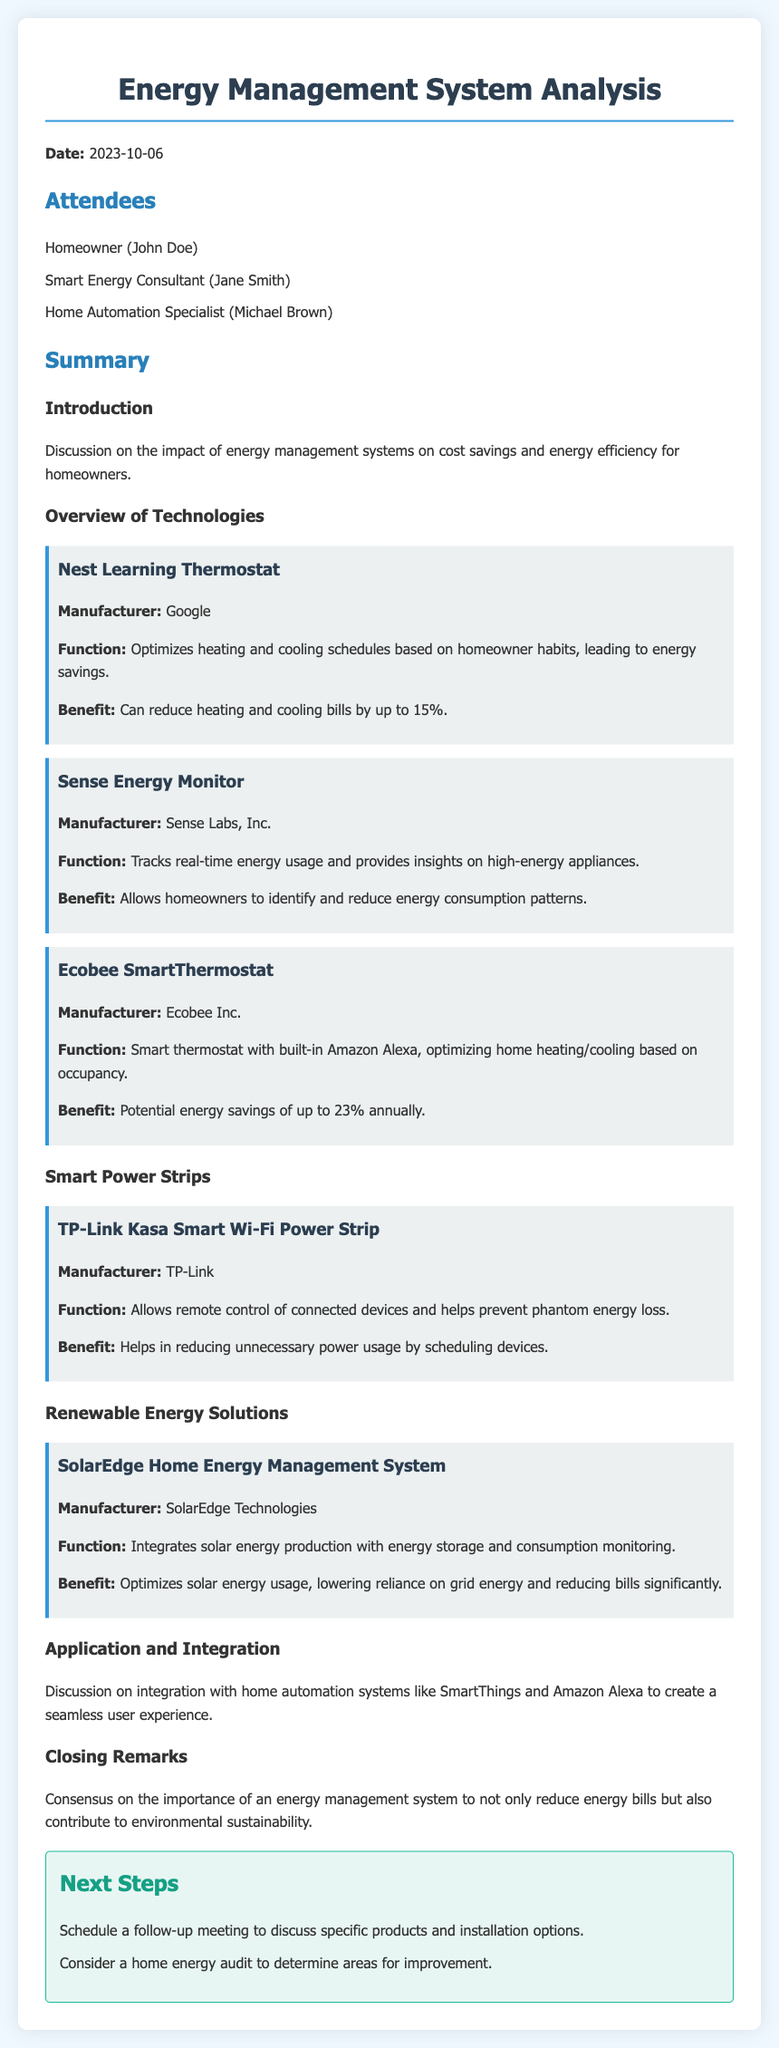What is the date of the meeting? The meeting took place on October 6, 2023.
Answer: October 6, 2023 Who is the manufacturer of the Nest Learning Thermostat? The manufacturer of the Nest Learning Thermostat is Google.
Answer: Google What percentage can the Ecobee SmartThermostat potentially save annually? The Ecobee SmartThermostat can save up to 23% annually.
Answer: 23% Which technology tracks real-time energy usage? The device that tracks real-time energy usage is the Sense Energy Monitor.
Answer: Sense Energy Monitor What is one benefit of using the TP-Link Kasa Smart Wi-Fi Power Strip? A benefit of the TP-Link Kasa Smart Wi-Fi Power Strip is it helps reduce unnecessary power usage.
Answer: Reduces unnecessary power usage What is a suggested next step in the meeting? One suggested next step is to schedule a follow-up meeting to discuss products and installation options.
Answer: Schedule a follow-up meeting What is the primary focus of the meeting? The primary focus of the meeting is on energy management systems for cost savings and energy efficiency.
Answer: Energy management systems What does the SolarEdge Home Energy Management System optimize? The SolarEdge Home Energy Management System optimizes solar energy usage.
Answer: Solar energy usage 